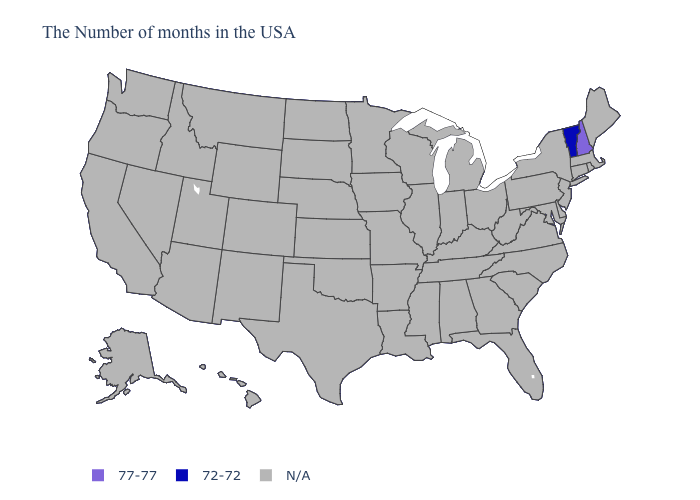How many symbols are there in the legend?
Quick response, please. 3. Does Vermont have the lowest value in the USA?
Be succinct. Yes. Name the states that have a value in the range N/A?
Write a very short answer. Maine, Massachusetts, Rhode Island, Connecticut, New York, New Jersey, Delaware, Maryland, Pennsylvania, Virginia, North Carolina, South Carolina, West Virginia, Ohio, Florida, Georgia, Michigan, Kentucky, Indiana, Alabama, Tennessee, Wisconsin, Illinois, Mississippi, Louisiana, Missouri, Arkansas, Minnesota, Iowa, Kansas, Nebraska, Oklahoma, Texas, South Dakota, North Dakota, Wyoming, Colorado, New Mexico, Utah, Montana, Arizona, Idaho, Nevada, California, Washington, Oregon, Alaska, Hawaii. What is the value of Texas?
Quick response, please. N/A. What is the lowest value in the USA?
Be succinct. 72-72. What is the value of Minnesota?
Keep it brief. N/A. What is the value of Michigan?
Quick response, please. N/A. Name the states that have a value in the range N/A?
Answer briefly. Maine, Massachusetts, Rhode Island, Connecticut, New York, New Jersey, Delaware, Maryland, Pennsylvania, Virginia, North Carolina, South Carolina, West Virginia, Ohio, Florida, Georgia, Michigan, Kentucky, Indiana, Alabama, Tennessee, Wisconsin, Illinois, Mississippi, Louisiana, Missouri, Arkansas, Minnesota, Iowa, Kansas, Nebraska, Oklahoma, Texas, South Dakota, North Dakota, Wyoming, Colorado, New Mexico, Utah, Montana, Arizona, Idaho, Nevada, California, Washington, Oregon, Alaska, Hawaii. What is the value of North Dakota?
Give a very brief answer. N/A. What is the value of New Mexico?
Short answer required. N/A. 